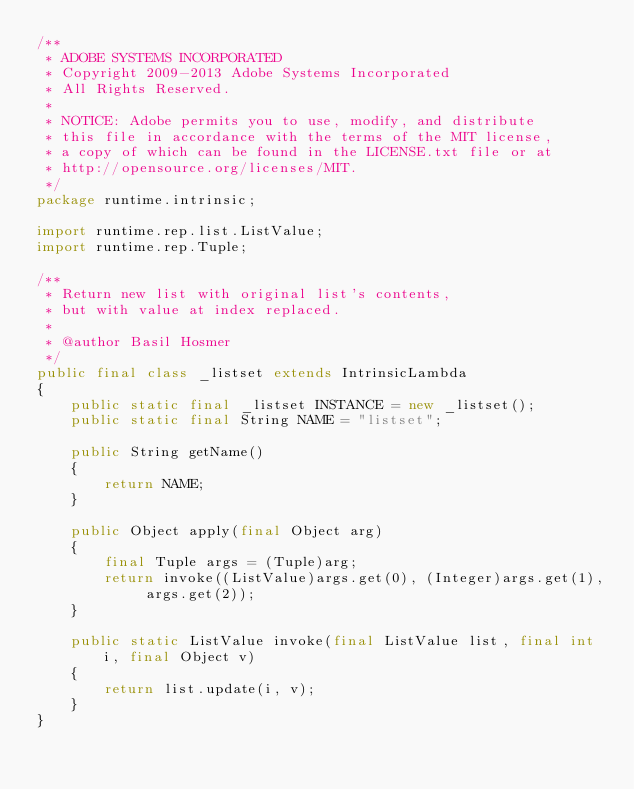Convert code to text. <code><loc_0><loc_0><loc_500><loc_500><_Java_>/**
 * ADOBE SYSTEMS INCORPORATED
 * Copyright 2009-2013 Adobe Systems Incorporated
 * All Rights Reserved.
 *
 * NOTICE: Adobe permits you to use, modify, and distribute
 * this file in accordance with the terms of the MIT license,
 * a copy of which can be found in the LICENSE.txt file or at
 * http://opensource.org/licenses/MIT.
 */
package runtime.intrinsic;

import runtime.rep.list.ListValue;
import runtime.rep.Tuple;

/**
 * Return new list with original list's contents,
 * but with value at index replaced.
 *
 * @author Basil Hosmer
 */
public final class _listset extends IntrinsicLambda
{
    public static final _listset INSTANCE = new _listset(); 
    public static final String NAME = "listset";

    public String getName()
    {
        return NAME;
    }

    public Object apply(final Object arg)
    {
        final Tuple args = (Tuple)arg;
        return invoke((ListValue)args.get(0), (Integer)args.get(1), args.get(2));
    }

    public static ListValue invoke(final ListValue list, final int i, final Object v)
    {
        return list.update(i, v);
    }
}
</code> 